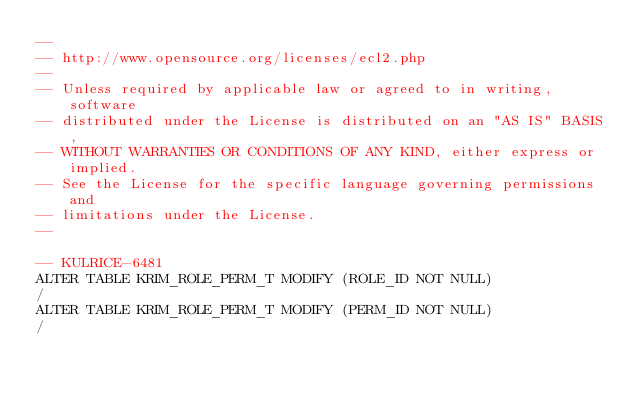<code> <loc_0><loc_0><loc_500><loc_500><_SQL_>--
-- http://www.opensource.org/licenses/ecl2.php
--
-- Unless required by applicable law or agreed to in writing, software
-- distributed under the License is distributed on an "AS IS" BASIS,
-- WITHOUT WARRANTIES OR CONDITIONS OF ANY KIND, either express or implied.
-- See the License for the specific language governing permissions and
-- limitations under the License.
--

-- KULRICE-6481
ALTER TABLE KRIM_ROLE_PERM_T MODIFY (ROLE_ID NOT NULL)
/
ALTER TABLE KRIM_ROLE_PERM_T MODIFY (PERM_ID NOT NULL)
/</code> 